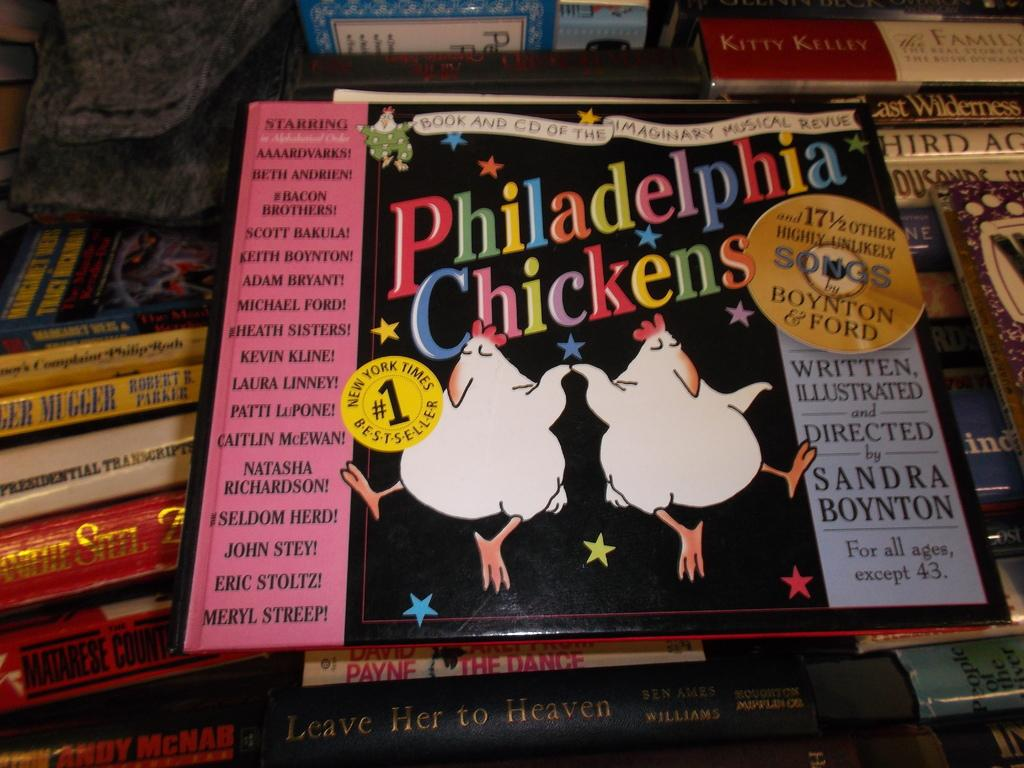<image>
Write a terse but informative summary of the picture. Two dancing chickens grace the gover a a book titled Philadelphia Chickens. 